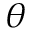Convert formula to latex. <formula><loc_0><loc_0><loc_500><loc_500>\theta</formula> 